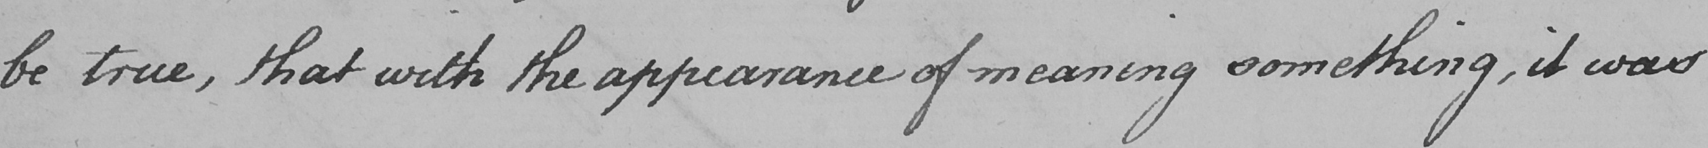What is written in this line of handwriting? be true , that with the appearance of meaning something , it was 